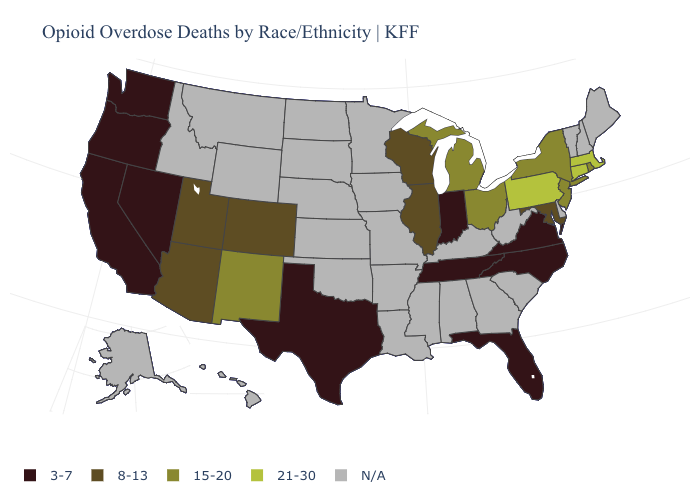Name the states that have a value in the range N/A?
Keep it brief. Alabama, Alaska, Arkansas, Delaware, Georgia, Hawaii, Idaho, Iowa, Kansas, Kentucky, Louisiana, Maine, Minnesota, Mississippi, Missouri, Montana, Nebraska, New Hampshire, North Dakota, Oklahoma, South Carolina, South Dakota, Vermont, West Virginia, Wyoming. What is the value of Louisiana?
Quick response, please. N/A. Does Connecticut have the highest value in the Northeast?
Write a very short answer. Yes. Which states hav the highest value in the MidWest?
Give a very brief answer. Michigan, Ohio. Does the first symbol in the legend represent the smallest category?
Write a very short answer. Yes. Does Oregon have the highest value in the USA?
Answer briefly. No. Name the states that have a value in the range 15-20?
Answer briefly. Michigan, New Jersey, New Mexico, New York, Ohio, Rhode Island. Does the map have missing data?
Quick response, please. Yes. What is the value of Kentucky?
Quick response, please. N/A. What is the value of Tennessee?
Answer briefly. 3-7. What is the value of Colorado?
Be succinct. 8-13. What is the highest value in the West ?
Write a very short answer. 15-20. Does California have the lowest value in the USA?
Answer briefly. Yes. Name the states that have a value in the range 3-7?
Be succinct. California, Florida, Indiana, Nevada, North Carolina, Oregon, Tennessee, Texas, Virginia, Washington. 